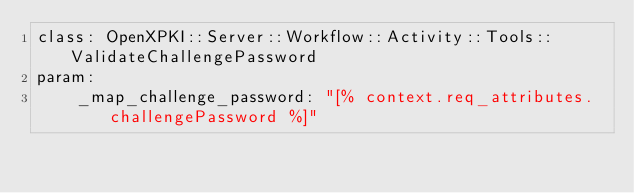<code> <loc_0><loc_0><loc_500><loc_500><_YAML_>class: OpenXPKI::Server::Workflow::Activity::Tools::ValidateChallengePassword
param:
    _map_challenge_password: "[% context.req_attributes.challengePassword %]"
</code> 